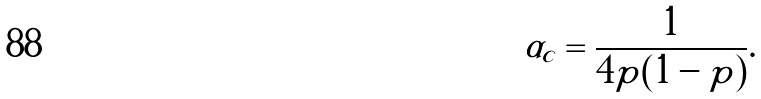<formula> <loc_0><loc_0><loc_500><loc_500>\alpha _ { c } = \frac { 1 } { 4 p ( 1 - p ) } .</formula> 